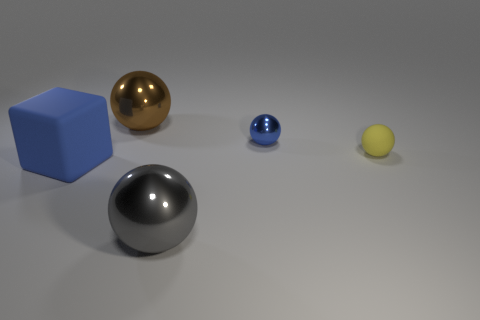Does the large sphere that is to the left of the big gray metallic thing have the same material as the tiny object to the right of the small blue sphere?
Make the answer very short. No. There is a small object that is the same color as the big rubber object; what is its shape?
Your response must be concise. Sphere. How many things are either tiny gray shiny objects or matte blocks that are in front of the yellow ball?
Your answer should be compact. 1. What color is the tiny shiny thing?
Offer a very short reply. Blue. What material is the blue thing that is left of the big ball in front of the rubber thing to the right of the small shiny sphere?
Make the answer very short. Rubber. What is the size of the yellow object that is the same material as the cube?
Keep it short and to the point. Small. Is there a tiny thing of the same color as the big matte thing?
Ensure brevity in your answer.  Yes. There is a blue rubber cube; is its size the same as the gray metal ball in front of the small yellow matte object?
Keep it short and to the point. Yes. How many small balls are on the right side of the large metallic object that is in front of the big rubber object that is on the left side of the small rubber thing?
Offer a very short reply. 2. What size is the thing that is the same color as the cube?
Provide a succinct answer. Small. 